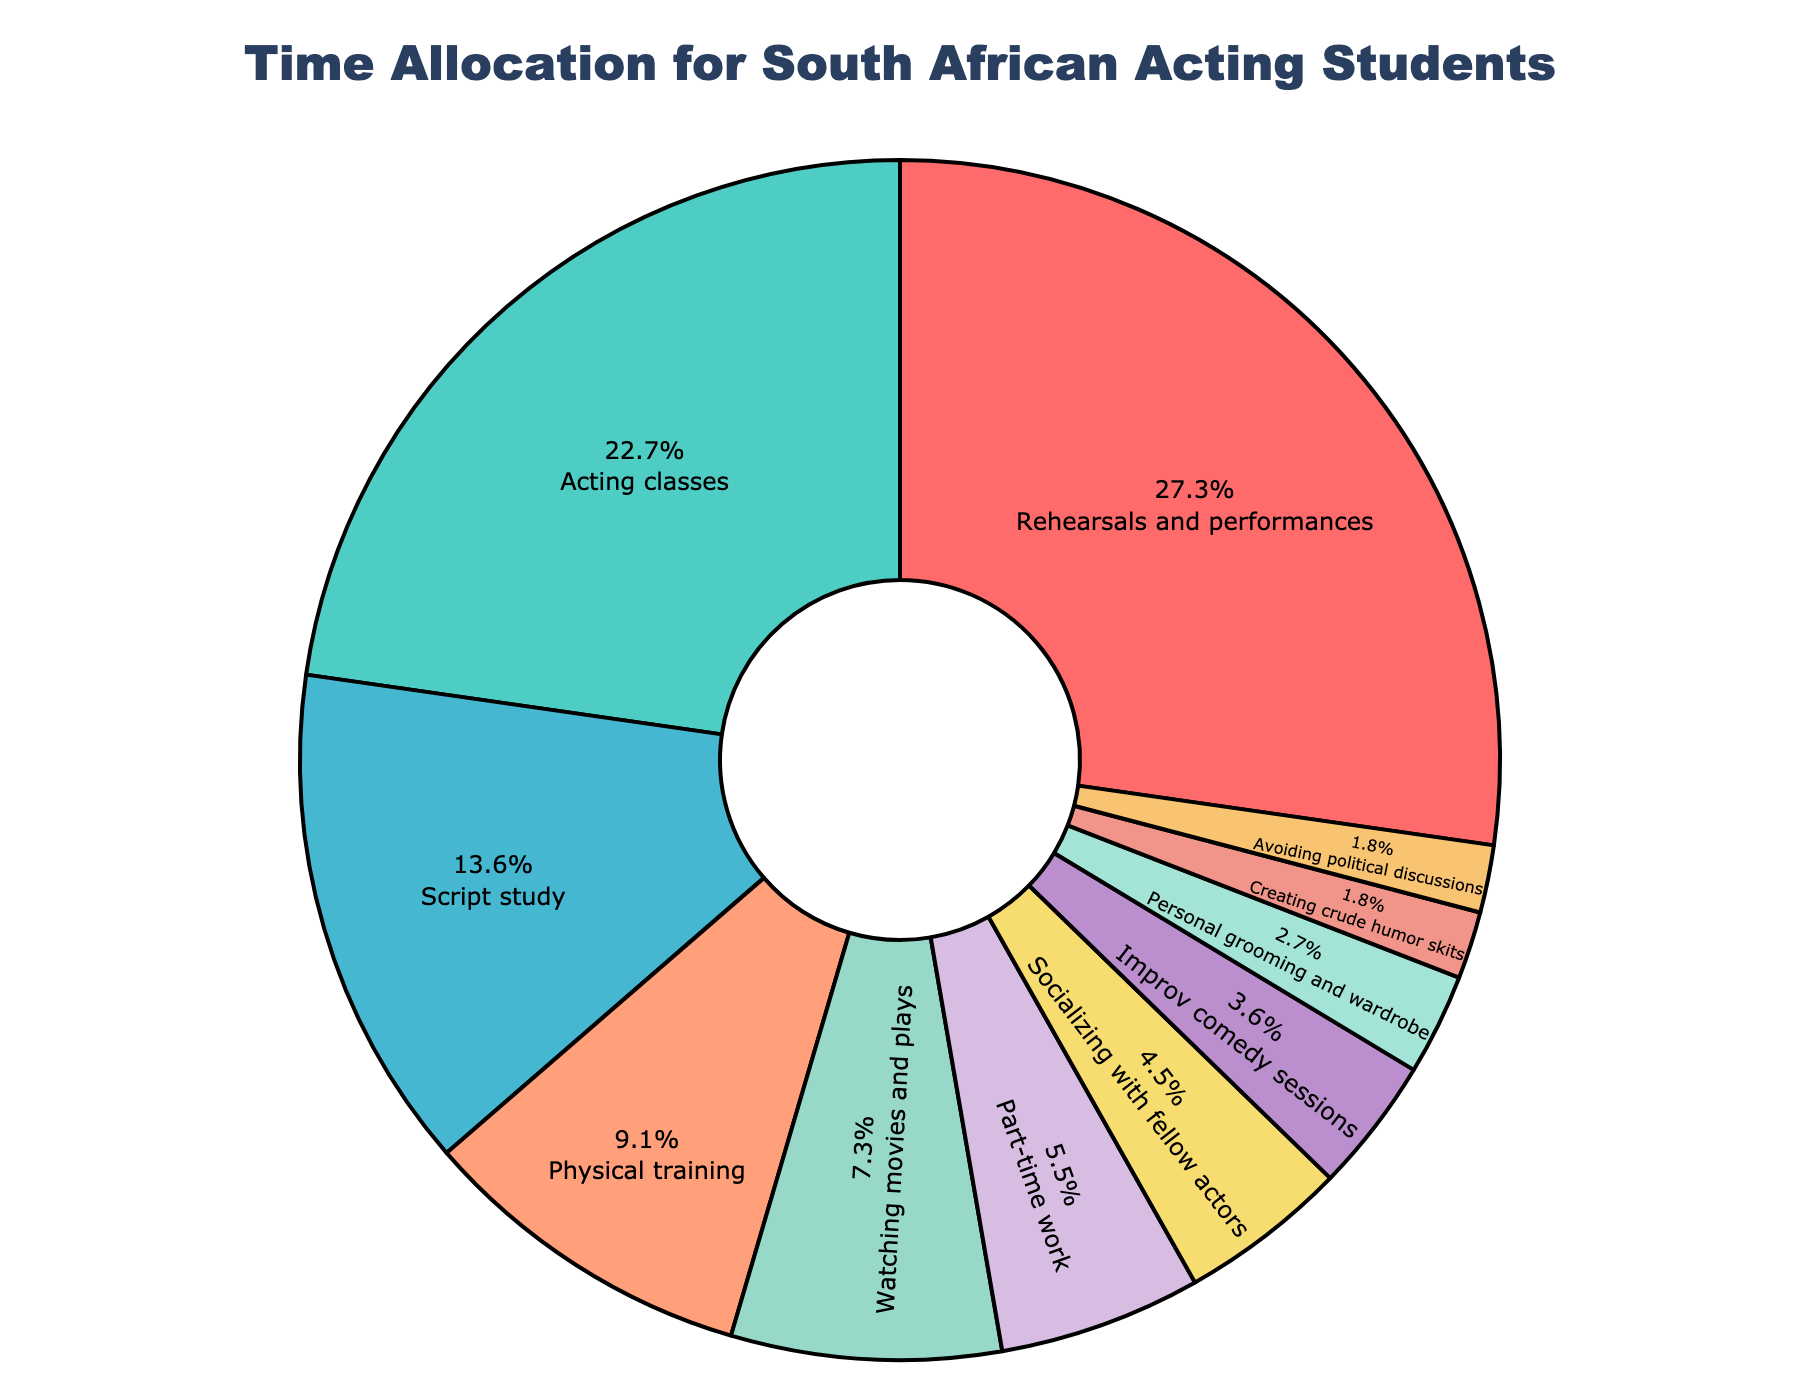What's the largest slice in the pie chart? The largest slice represents the activity with the highest percentage of time allocation. By looking at the chart, "Rehearsals and performances" occupies the largest slice.
Answer: Rehearsals and performances How much more time is spent on rehearsals and performances compared to acting classes? The pie chart shows rehearsals and performances take 30%, while acting classes take 25%. The difference in percentage can be calculated as \(30\% - 25\% = 5\%\).
Answer: 5% What's the total percentage of time spent on social activities including socializing with fellow actors and improv comedy sessions? Socializing with fellow actors takes 5% and improv comedy sessions take 4%. Adding these percentages together gives \(5\% + 4\% = 9\%\).
Answer: 9% Which activity is represented by the smallest slice in the pie chart? Examine the slices to determine which one occupies the least space. "Creating crude humor skits" and "Avoiding political discussions" both take up 2%, representing the smallest slices.
Answer: Creating crude humor skits and Avoiding political discussions What is the combined percentage of time spent on physical training and personal grooming and wardrobe? Physical training takes 10% and personal grooming and wardrobe takes 3%. Adding these percentages gives \(10\% + 3\% = 13\%\).
Answer: 13% How does the time spent on watching movies and plays compare to the time spent on script study? Watching movies and plays occupies 8% of the time, while script study occupies 15%. Clearly, more time is spent on script study.
Answer: Script study is higher If you combine rehearsals and performances, acting classes, and script study, what fraction of time does this represent? Rehearsals and performances take 30%, acting classes take 25%, and script study takes 15%. Adding these percentages gives \(30\% + 25\% + 15\% = 70\%\).
Answer: 70% Which visual attribute helps you identify the activity of ‘Avoiding political discussions’? The pie slice for 'Avoiding political discussions' is colored, and since it takes up the smallest percentage (2%), it is one of the two smallest slices, making it easy to identify visually.
Answer: Color and size (smallest slice) What is the percentage difference between time spent on personal grooming and wardrobe and creating crude humor skits? Personal grooming and wardrobe occupies 3% of the time, while creating crude humor skits takes 2%. The difference can be calculated as \(3\% - 2\% = 1\%\).
Answer: 1% 